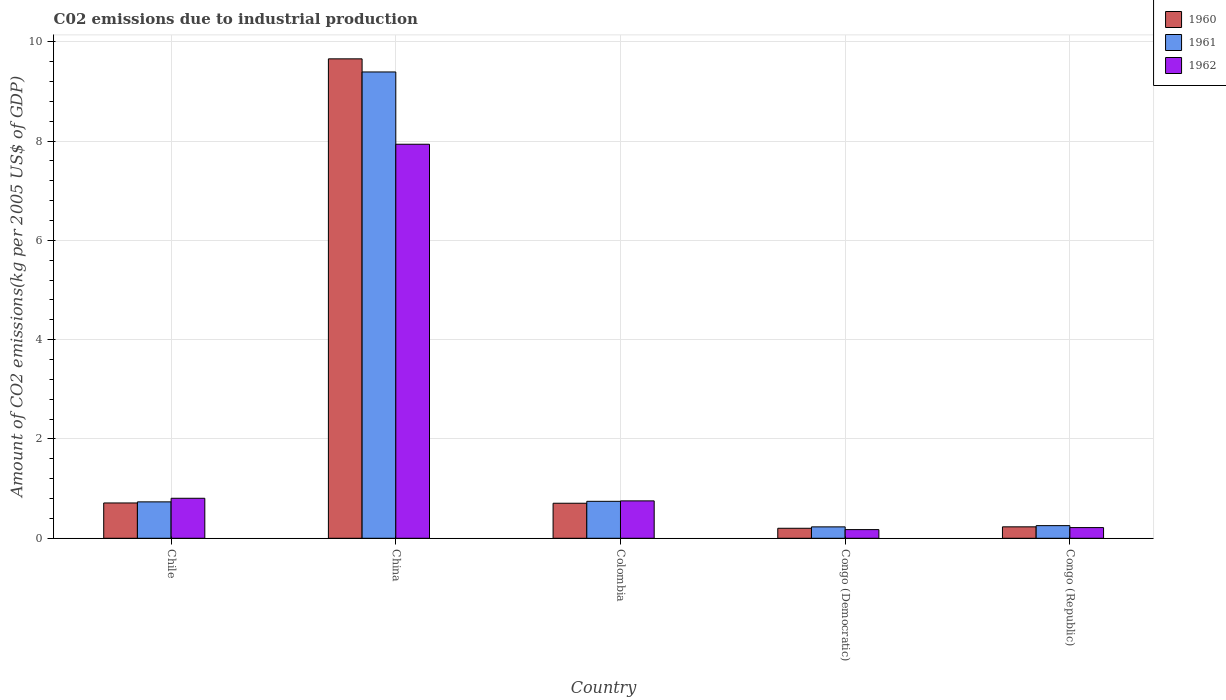How many different coloured bars are there?
Provide a succinct answer. 3. Are the number of bars per tick equal to the number of legend labels?
Provide a short and direct response. Yes. How many bars are there on the 1st tick from the left?
Your response must be concise. 3. What is the label of the 4th group of bars from the left?
Keep it short and to the point. Congo (Democratic). What is the amount of CO2 emitted due to industrial production in 1962 in China?
Your answer should be very brief. 7.94. Across all countries, what is the maximum amount of CO2 emitted due to industrial production in 1962?
Provide a short and direct response. 7.94. Across all countries, what is the minimum amount of CO2 emitted due to industrial production in 1961?
Provide a short and direct response. 0.23. In which country was the amount of CO2 emitted due to industrial production in 1962 maximum?
Your answer should be compact. China. In which country was the amount of CO2 emitted due to industrial production in 1962 minimum?
Offer a very short reply. Congo (Democratic). What is the total amount of CO2 emitted due to industrial production in 1960 in the graph?
Provide a short and direct response. 11.51. What is the difference between the amount of CO2 emitted due to industrial production in 1961 in China and that in Congo (Democratic)?
Provide a short and direct response. 9.16. What is the difference between the amount of CO2 emitted due to industrial production in 1962 in Congo (Democratic) and the amount of CO2 emitted due to industrial production in 1961 in Congo (Republic)?
Provide a short and direct response. -0.08. What is the average amount of CO2 emitted due to industrial production in 1962 per country?
Offer a very short reply. 1.98. What is the difference between the amount of CO2 emitted due to industrial production of/in 1962 and amount of CO2 emitted due to industrial production of/in 1961 in Colombia?
Offer a terse response. 0.01. What is the ratio of the amount of CO2 emitted due to industrial production in 1962 in China to that in Congo (Republic)?
Make the answer very short. 36.82. Is the difference between the amount of CO2 emitted due to industrial production in 1962 in China and Congo (Democratic) greater than the difference between the amount of CO2 emitted due to industrial production in 1961 in China and Congo (Democratic)?
Offer a very short reply. No. What is the difference between the highest and the second highest amount of CO2 emitted due to industrial production in 1962?
Your answer should be compact. 0.05. What is the difference between the highest and the lowest amount of CO2 emitted due to industrial production in 1962?
Offer a very short reply. 7.76. What does the 1st bar from the left in Colombia represents?
Keep it short and to the point. 1960. What does the 1st bar from the right in Congo (Republic) represents?
Offer a terse response. 1962. Is it the case that in every country, the sum of the amount of CO2 emitted due to industrial production in 1960 and amount of CO2 emitted due to industrial production in 1961 is greater than the amount of CO2 emitted due to industrial production in 1962?
Keep it short and to the point. Yes. How many bars are there?
Make the answer very short. 15. Are all the bars in the graph horizontal?
Provide a succinct answer. No. How many countries are there in the graph?
Ensure brevity in your answer.  5. Are the values on the major ticks of Y-axis written in scientific E-notation?
Offer a very short reply. No. Does the graph contain any zero values?
Your response must be concise. No. Where does the legend appear in the graph?
Your response must be concise. Top right. How are the legend labels stacked?
Your response must be concise. Vertical. What is the title of the graph?
Give a very brief answer. C02 emissions due to industrial production. What is the label or title of the Y-axis?
Your answer should be compact. Amount of CO2 emissions(kg per 2005 US$ of GDP). What is the Amount of CO2 emissions(kg per 2005 US$ of GDP) in 1960 in Chile?
Give a very brief answer. 0.71. What is the Amount of CO2 emissions(kg per 2005 US$ of GDP) of 1961 in Chile?
Offer a terse response. 0.73. What is the Amount of CO2 emissions(kg per 2005 US$ of GDP) in 1962 in Chile?
Make the answer very short. 0.81. What is the Amount of CO2 emissions(kg per 2005 US$ of GDP) in 1960 in China?
Give a very brief answer. 9.66. What is the Amount of CO2 emissions(kg per 2005 US$ of GDP) in 1961 in China?
Your answer should be compact. 9.39. What is the Amount of CO2 emissions(kg per 2005 US$ of GDP) of 1962 in China?
Your answer should be compact. 7.94. What is the Amount of CO2 emissions(kg per 2005 US$ of GDP) in 1960 in Colombia?
Provide a succinct answer. 0.71. What is the Amount of CO2 emissions(kg per 2005 US$ of GDP) of 1961 in Colombia?
Your answer should be very brief. 0.74. What is the Amount of CO2 emissions(kg per 2005 US$ of GDP) in 1962 in Colombia?
Your response must be concise. 0.75. What is the Amount of CO2 emissions(kg per 2005 US$ of GDP) in 1960 in Congo (Democratic)?
Keep it short and to the point. 0.2. What is the Amount of CO2 emissions(kg per 2005 US$ of GDP) of 1961 in Congo (Democratic)?
Keep it short and to the point. 0.23. What is the Amount of CO2 emissions(kg per 2005 US$ of GDP) of 1962 in Congo (Democratic)?
Your answer should be compact. 0.17. What is the Amount of CO2 emissions(kg per 2005 US$ of GDP) in 1960 in Congo (Republic)?
Ensure brevity in your answer.  0.23. What is the Amount of CO2 emissions(kg per 2005 US$ of GDP) of 1961 in Congo (Republic)?
Provide a succinct answer. 0.25. What is the Amount of CO2 emissions(kg per 2005 US$ of GDP) of 1962 in Congo (Republic)?
Provide a succinct answer. 0.22. Across all countries, what is the maximum Amount of CO2 emissions(kg per 2005 US$ of GDP) in 1960?
Provide a succinct answer. 9.66. Across all countries, what is the maximum Amount of CO2 emissions(kg per 2005 US$ of GDP) in 1961?
Make the answer very short. 9.39. Across all countries, what is the maximum Amount of CO2 emissions(kg per 2005 US$ of GDP) of 1962?
Make the answer very short. 7.94. Across all countries, what is the minimum Amount of CO2 emissions(kg per 2005 US$ of GDP) of 1960?
Provide a short and direct response. 0.2. Across all countries, what is the minimum Amount of CO2 emissions(kg per 2005 US$ of GDP) of 1961?
Provide a short and direct response. 0.23. Across all countries, what is the minimum Amount of CO2 emissions(kg per 2005 US$ of GDP) in 1962?
Give a very brief answer. 0.17. What is the total Amount of CO2 emissions(kg per 2005 US$ of GDP) in 1960 in the graph?
Keep it short and to the point. 11.51. What is the total Amount of CO2 emissions(kg per 2005 US$ of GDP) of 1961 in the graph?
Ensure brevity in your answer.  11.36. What is the total Amount of CO2 emissions(kg per 2005 US$ of GDP) of 1962 in the graph?
Your answer should be very brief. 9.89. What is the difference between the Amount of CO2 emissions(kg per 2005 US$ of GDP) of 1960 in Chile and that in China?
Keep it short and to the point. -8.95. What is the difference between the Amount of CO2 emissions(kg per 2005 US$ of GDP) in 1961 in Chile and that in China?
Provide a short and direct response. -8.66. What is the difference between the Amount of CO2 emissions(kg per 2005 US$ of GDP) of 1962 in Chile and that in China?
Keep it short and to the point. -7.13. What is the difference between the Amount of CO2 emissions(kg per 2005 US$ of GDP) in 1960 in Chile and that in Colombia?
Provide a succinct answer. 0.01. What is the difference between the Amount of CO2 emissions(kg per 2005 US$ of GDP) of 1961 in Chile and that in Colombia?
Keep it short and to the point. -0.01. What is the difference between the Amount of CO2 emissions(kg per 2005 US$ of GDP) of 1962 in Chile and that in Colombia?
Your answer should be very brief. 0.05. What is the difference between the Amount of CO2 emissions(kg per 2005 US$ of GDP) in 1960 in Chile and that in Congo (Democratic)?
Provide a short and direct response. 0.51. What is the difference between the Amount of CO2 emissions(kg per 2005 US$ of GDP) in 1961 in Chile and that in Congo (Democratic)?
Provide a short and direct response. 0.5. What is the difference between the Amount of CO2 emissions(kg per 2005 US$ of GDP) in 1962 in Chile and that in Congo (Democratic)?
Your answer should be very brief. 0.63. What is the difference between the Amount of CO2 emissions(kg per 2005 US$ of GDP) of 1960 in Chile and that in Congo (Republic)?
Give a very brief answer. 0.48. What is the difference between the Amount of CO2 emissions(kg per 2005 US$ of GDP) in 1961 in Chile and that in Congo (Republic)?
Your response must be concise. 0.48. What is the difference between the Amount of CO2 emissions(kg per 2005 US$ of GDP) of 1962 in Chile and that in Congo (Republic)?
Keep it short and to the point. 0.59. What is the difference between the Amount of CO2 emissions(kg per 2005 US$ of GDP) in 1960 in China and that in Colombia?
Keep it short and to the point. 8.95. What is the difference between the Amount of CO2 emissions(kg per 2005 US$ of GDP) of 1961 in China and that in Colombia?
Ensure brevity in your answer.  8.65. What is the difference between the Amount of CO2 emissions(kg per 2005 US$ of GDP) in 1962 in China and that in Colombia?
Your answer should be compact. 7.18. What is the difference between the Amount of CO2 emissions(kg per 2005 US$ of GDP) of 1960 in China and that in Congo (Democratic)?
Provide a succinct answer. 9.46. What is the difference between the Amount of CO2 emissions(kg per 2005 US$ of GDP) of 1961 in China and that in Congo (Democratic)?
Your answer should be compact. 9.16. What is the difference between the Amount of CO2 emissions(kg per 2005 US$ of GDP) in 1962 in China and that in Congo (Democratic)?
Make the answer very short. 7.76. What is the difference between the Amount of CO2 emissions(kg per 2005 US$ of GDP) of 1960 in China and that in Congo (Republic)?
Offer a terse response. 9.43. What is the difference between the Amount of CO2 emissions(kg per 2005 US$ of GDP) in 1961 in China and that in Congo (Republic)?
Provide a succinct answer. 9.14. What is the difference between the Amount of CO2 emissions(kg per 2005 US$ of GDP) of 1962 in China and that in Congo (Republic)?
Offer a terse response. 7.72. What is the difference between the Amount of CO2 emissions(kg per 2005 US$ of GDP) in 1960 in Colombia and that in Congo (Democratic)?
Your response must be concise. 0.5. What is the difference between the Amount of CO2 emissions(kg per 2005 US$ of GDP) of 1961 in Colombia and that in Congo (Democratic)?
Provide a succinct answer. 0.51. What is the difference between the Amount of CO2 emissions(kg per 2005 US$ of GDP) of 1962 in Colombia and that in Congo (Democratic)?
Ensure brevity in your answer.  0.58. What is the difference between the Amount of CO2 emissions(kg per 2005 US$ of GDP) of 1960 in Colombia and that in Congo (Republic)?
Provide a succinct answer. 0.48. What is the difference between the Amount of CO2 emissions(kg per 2005 US$ of GDP) of 1961 in Colombia and that in Congo (Republic)?
Ensure brevity in your answer.  0.49. What is the difference between the Amount of CO2 emissions(kg per 2005 US$ of GDP) in 1962 in Colombia and that in Congo (Republic)?
Your answer should be very brief. 0.54. What is the difference between the Amount of CO2 emissions(kg per 2005 US$ of GDP) in 1960 in Congo (Democratic) and that in Congo (Republic)?
Ensure brevity in your answer.  -0.03. What is the difference between the Amount of CO2 emissions(kg per 2005 US$ of GDP) of 1961 in Congo (Democratic) and that in Congo (Republic)?
Make the answer very short. -0.02. What is the difference between the Amount of CO2 emissions(kg per 2005 US$ of GDP) of 1962 in Congo (Democratic) and that in Congo (Republic)?
Provide a short and direct response. -0.04. What is the difference between the Amount of CO2 emissions(kg per 2005 US$ of GDP) of 1960 in Chile and the Amount of CO2 emissions(kg per 2005 US$ of GDP) of 1961 in China?
Give a very brief answer. -8.68. What is the difference between the Amount of CO2 emissions(kg per 2005 US$ of GDP) in 1960 in Chile and the Amount of CO2 emissions(kg per 2005 US$ of GDP) in 1962 in China?
Give a very brief answer. -7.23. What is the difference between the Amount of CO2 emissions(kg per 2005 US$ of GDP) in 1961 in Chile and the Amount of CO2 emissions(kg per 2005 US$ of GDP) in 1962 in China?
Ensure brevity in your answer.  -7.2. What is the difference between the Amount of CO2 emissions(kg per 2005 US$ of GDP) in 1960 in Chile and the Amount of CO2 emissions(kg per 2005 US$ of GDP) in 1961 in Colombia?
Your answer should be very brief. -0.03. What is the difference between the Amount of CO2 emissions(kg per 2005 US$ of GDP) in 1960 in Chile and the Amount of CO2 emissions(kg per 2005 US$ of GDP) in 1962 in Colombia?
Give a very brief answer. -0.04. What is the difference between the Amount of CO2 emissions(kg per 2005 US$ of GDP) in 1961 in Chile and the Amount of CO2 emissions(kg per 2005 US$ of GDP) in 1962 in Colombia?
Provide a short and direct response. -0.02. What is the difference between the Amount of CO2 emissions(kg per 2005 US$ of GDP) of 1960 in Chile and the Amount of CO2 emissions(kg per 2005 US$ of GDP) of 1961 in Congo (Democratic)?
Provide a short and direct response. 0.48. What is the difference between the Amount of CO2 emissions(kg per 2005 US$ of GDP) in 1960 in Chile and the Amount of CO2 emissions(kg per 2005 US$ of GDP) in 1962 in Congo (Democratic)?
Your answer should be very brief. 0.54. What is the difference between the Amount of CO2 emissions(kg per 2005 US$ of GDP) in 1961 in Chile and the Amount of CO2 emissions(kg per 2005 US$ of GDP) in 1962 in Congo (Democratic)?
Offer a very short reply. 0.56. What is the difference between the Amount of CO2 emissions(kg per 2005 US$ of GDP) in 1960 in Chile and the Amount of CO2 emissions(kg per 2005 US$ of GDP) in 1961 in Congo (Republic)?
Your answer should be compact. 0.46. What is the difference between the Amount of CO2 emissions(kg per 2005 US$ of GDP) of 1960 in Chile and the Amount of CO2 emissions(kg per 2005 US$ of GDP) of 1962 in Congo (Republic)?
Your response must be concise. 0.5. What is the difference between the Amount of CO2 emissions(kg per 2005 US$ of GDP) of 1961 in Chile and the Amount of CO2 emissions(kg per 2005 US$ of GDP) of 1962 in Congo (Republic)?
Give a very brief answer. 0.52. What is the difference between the Amount of CO2 emissions(kg per 2005 US$ of GDP) of 1960 in China and the Amount of CO2 emissions(kg per 2005 US$ of GDP) of 1961 in Colombia?
Provide a succinct answer. 8.91. What is the difference between the Amount of CO2 emissions(kg per 2005 US$ of GDP) in 1960 in China and the Amount of CO2 emissions(kg per 2005 US$ of GDP) in 1962 in Colombia?
Provide a succinct answer. 8.9. What is the difference between the Amount of CO2 emissions(kg per 2005 US$ of GDP) of 1961 in China and the Amount of CO2 emissions(kg per 2005 US$ of GDP) of 1962 in Colombia?
Offer a very short reply. 8.64. What is the difference between the Amount of CO2 emissions(kg per 2005 US$ of GDP) of 1960 in China and the Amount of CO2 emissions(kg per 2005 US$ of GDP) of 1961 in Congo (Democratic)?
Offer a very short reply. 9.43. What is the difference between the Amount of CO2 emissions(kg per 2005 US$ of GDP) in 1960 in China and the Amount of CO2 emissions(kg per 2005 US$ of GDP) in 1962 in Congo (Democratic)?
Ensure brevity in your answer.  9.48. What is the difference between the Amount of CO2 emissions(kg per 2005 US$ of GDP) in 1961 in China and the Amount of CO2 emissions(kg per 2005 US$ of GDP) in 1962 in Congo (Democratic)?
Your answer should be compact. 9.22. What is the difference between the Amount of CO2 emissions(kg per 2005 US$ of GDP) in 1960 in China and the Amount of CO2 emissions(kg per 2005 US$ of GDP) in 1961 in Congo (Republic)?
Make the answer very short. 9.4. What is the difference between the Amount of CO2 emissions(kg per 2005 US$ of GDP) in 1960 in China and the Amount of CO2 emissions(kg per 2005 US$ of GDP) in 1962 in Congo (Republic)?
Your response must be concise. 9.44. What is the difference between the Amount of CO2 emissions(kg per 2005 US$ of GDP) of 1961 in China and the Amount of CO2 emissions(kg per 2005 US$ of GDP) of 1962 in Congo (Republic)?
Your answer should be compact. 9.18. What is the difference between the Amount of CO2 emissions(kg per 2005 US$ of GDP) of 1960 in Colombia and the Amount of CO2 emissions(kg per 2005 US$ of GDP) of 1961 in Congo (Democratic)?
Ensure brevity in your answer.  0.48. What is the difference between the Amount of CO2 emissions(kg per 2005 US$ of GDP) in 1960 in Colombia and the Amount of CO2 emissions(kg per 2005 US$ of GDP) in 1962 in Congo (Democratic)?
Offer a very short reply. 0.53. What is the difference between the Amount of CO2 emissions(kg per 2005 US$ of GDP) in 1961 in Colombia and the Amount of CO2 emissions(kg per 2005 US$ of GDP) in 1962 in Congo (Democratic)?
Provide a short and direct response. 0.57. What is the difference between the Amount of CO2 emissions(kg per 2005 US$ of GDP) in 1960 in Colombia and the Amount of CO2 emissions(kg per 2005 US$ of GDP) in 1961 in Congo (Republic)?
Offer a very short reply. 0.45. What is the difference between the Amount of CO2 emissions(kg per 2005 US$ of GDP) in 1960 in Colombia and the Amount of CO2 emissions(kg per 2005 US$ of GDP) in 1962 in Congo (Republic)?
Offer a very short reply. 0.49. What is the difference between the Amount of CO2 emissions(kg per 2005 US$ of GDP) in 1961 in Colombia and the Amount of CO2 emissions(kg per 2005 US$ of GDP) in 1962 in Congo (Republic)?
Provide a succinct answer. 0.53. What is the difference between the Amount of CO2 emissions(kg per 2005 US$ of GDP) in 1960 in Congo (Democratic) and the Amount of CO2 emissions(kg per 2005 US$ of GDP) in 1961 in Congo (Republic)?
Your response must be concise. -0.05. What is the difference between the Amount of CO2 emissions(kg per 2005 US$ of GDP) of 1960 in Congo (Democratic) and the Amount of CO2 emissions(kg per 2005 US$ of GDP) of 1962 in Congo (Republic)?
Make the answer very short. -0.01. What is the difference between the Amount of CO2 emissions(kg per 2005 US$ of GDP) in 1961 in Congo (Democratic) and the Amount of CO2 emissions(kg per 2005 US$ of GDP) in 1962 in Congo (Republic)?
Offer a terse response. 0.01. What is the average Amount of CO2 emissions(kg per 2005 US$ of GDP) of 1960 per country?
Ensure brevity in your answer.  2.3. What is the average Amount of CO2 emissions(kg per 2005 US$ of GDP) of 1961 per country?
Provide a short and direct response. 2.27. What is the average Amount of CO2 emissions(kg per 2005 US$ of GDP) of 1962 per country?
Give a very brief answer. 1.98. What is the difference between the Amount of CO2 emissions(kg per 2005 US$ of GDP) in 1960 and Amount of CO2 emissions(kg per 2005 US$ of GDP) in 1961 in Chile?
Your response must be concise. -0.02. What is the difference between the Amount of CO2 emissions(kg per 2005 US$ of GDP) of 1960 and Amount of CO2 emissions(kg per 2005 US$ of GDP) of 1962 in Chile?
Offer a very short reply. -0.09. What is the difference between the Amount of CO2 emissions(kg per 2005 US$ of GDP) in 1961 and Amount of CO2 emissions(kg per 2005 US$ of GDP) in 1962 in Chile?
Make the answer very short. -0.07. What is the difference between the Amount of CO2 emissions(kg per 2005 US$ of GDP) of 1960 and Amount of CO2 emissions(kg per 2005 US$ of GDP) of 1961 in China?
Keep it short and to the point. 0.26. What is the difference between the Amount of CO2 emissions(kg per 2005 US$ of GDP) of 1960 and Amount of CO2 emissions(kg per 2005 US$ of GDP) of 1962 in China?
Give a very brief answer. 1.72. What is the difference between the Amount of CO2 emissions(kg per 2005 US$ of GDP) of 1961 and Amount of CO2 emissions(kg per 2005 US$ of GDP) of 1962 in China?
Ensure brevity in your answer.  1.46. What is the difference between the Amount of CO2 emissions(kg per 2005 US$ of GDP) of 1960 and Amount of CO2 emissions(kg per 2005 US$ of GDP) of 1961 in Colombia?
Offer a very short reply. -0.04. What is the difference between the Amount of CO2 emissions(kg per 2005 US$ of GDP) in 1960 and Amount of CO2 emissions(kg per 2005 US$ of GDP) in 1962 in Colombia?
Make the answer very short. -0.05. What is the difference between the Amount of CO2 emissions(kg per 2005 US$ of GDP) in 1961 and Amount of CO2 emissions(kg per 2005 US$ of GDP) in 1962 in Colombia?
Make the answer very short. -0.01. What is the difference between the Amount of CO2 emissions(kg per 2005 US$ of GDP) in 1960 and Amount of CO2 emissions(kg per 2005 US$ of GDP) in 1961 in Congo (Democratic)?
Make the answer very short. -0.03. What is the difference between the Amount of CO2 emissions(kg per 2005 US$ of GDP) in 1960 and Amount of CO2 emissions(kg per 2005 US$ of GDP) in 1962 in Congo (Democratic)?
Make the answer very short. 0.03. What is the difference between the Amount of CO2 emissions(kg per 2005 US$ of GDP) in 1961 and Amount of CO2 emissions(kg per 2005 US$ of GDP) in 1962 in Congo (Democratic)?
Provide a short and direct response. 0.05. What is the difference between the Amount of CO2 emissions(kg per 2005 US$ of GDP) of 1960 and Amount of CO2 emissions(kg per 2005 US$ of GDP) of 1961 in Congo (Republic)?
Give a very brief answer. -0.02. What is the difference between the Amount of CO2 emissions(kg per 2005 US$ of GDP) in 1960 and Amount of CO2 emissions(kg per 2005 US$ of GDP) in 1962 in Congo (Republic)?
Provide a short and direct response. 0.01. What is the difference between the Amount of CO2 emissions(kg per 2005 US$ of GDP) in 1961 and Amount of CO2 emissions(kg per 2005 US$ of GDP) in 1962 in Congo (Republic)?
Keep it short and to the point. 0.04. What is the ratio of the Amount of CO2 emissions(kg per 2005 US$ of GDP) of 1960 in Chile to that in China?
Ensure brevity in your answer.  0.07. What is the ratio of the Amount of CO2 emissions(kg per 2005 US$ of GDP) in 1961 in Chile to that in China?
Keep it short and to the point. 0.08. What is the ratio of the Amount of CO2 emissions(kg per 2005 US$ of GDP) in 1962 in Chile to that in China?
Give a very brief answer. 0.1. What is the ratio of the Amount of CO2 emissions(kg per 2005 US$ of GDP) of 1961 in Chile to that in Colombia?
Make the answer very short. 0.99. What is the ratio of the Amount of CO2 emissions(kg per 2005 US$ of GDP) in 1962 in Chile to that in Colombia?
Keep it short and to the point. 1.07. What is the ratio of the Amount of CO2 emissions(kg per 2005 US$ of GDP) of 1960 in Chile to that in Congo (Democratic)?
Ensure brevity in your answer.  3.53. What is the ratio of the Amount of CO2 emissions(kg per 2005 US$ of GDP) of 1961 in Chile to that in Congo (Democratic)?
Give a very brief answer. 3.19. What is the ratio of the Amount of CO2 emissions(kg per 2005 US$ of GDP) in 1962 in Chile to that in Congo (Democratic)?
Keep it short and to the point. 4.61. What is the ratio of the Amount of CO2 emissions(kg per 2005 US$ of GDP) in 1960 in Chile to that in Congo (Republic)?
Make the answer very short. 3.08. What is the ratio of the Amount of CO2 emissions(kg per 2005 US$ of GDP) of 1961 in Chile to that in Congo (Republic)?
Offer a very short reply. 2.88. What is the ratio of the Amount of CO2 emissions(kg per 2005 US$ of GDP) in 1962 in Chile to that in Congo (Republic)?
Your answer should be compact. 3.74. What is the ratio of the Amount of CO2 emissions(kg per 2005 US$ of GDP) of 1960 in China to that in Colombia?
Ensure brevity in your answer.  13.68. What is the ratio of the Amount of CO2 emissions(kg per 2005 US$ of GDP) in 1961 in China to that in Colombia?
Give a very brief answer. 12.62. What is the ratio of the Amount of CO2 emissions(kg per 2005 US$ of GDP) in 1962 in China to that in Colombia?
Make the answer very short. 10.54. What is the ratio of the Amount of CO2 emissions(kg per 2005 US$ of GDP) in 1960 in China to that in Congo (Democratic)?
Keep it short and to the point. 47.89. What is the ratio of the Amount of CO2 emissions(kg per 2005 US$ of GDP) in 1961 in China to that in Congo (Democratic)?
Your response must be concise. 40.88. What is the ratio of the Amount of CO2 emissions(kg per 2005 US$ of GDP) of 1962 in China to that in Congo (Democratic)?
Make the answer very short. 45.4. What is the ratio of the Amount of CO2 emissions(kg per 2005 US$ of GDP) in 1960 in China to that in Congo (Republic)?
Ensure brevity in your answer.  41.88. What is the ratio of the Amount of CO2 emissions(kg per 2005 US$ of GDP) of 1961 in China to that in Congo (Republic)?
Provide a short and direct response. 36.88. What is the ratio of the Amount of CO2 emissions(kg per 2005 US$ of GDP) of 1962 in China to that in Congo (Republic)?
Your answer should be very brief. 36.82. What is the ratio of the Amount of CO2 emissions(kg per 2005 US$ of GDP) of 1961 in Colombia to that in Congo (Democratic)?
Provide a short and direct response. 3.24. What is the ratio of the Amount of CO2 emissions(kg per 2005 US$ of GDP) of 1962 in Colombia to that in Congo (Democratic)?
Your answer should be compact. 4.31. What is the ratio of the Amount of CO2 emissions(kg per 2005 US$ of GDP) in 1960 in Colombia to that in Congo (Republic)?
Ensure brevity in your answer.  3.06. What is the ratio of the Amount of CO2 emissions(kg per 2005 US$ of GDP) of 1961 in Colombia to that in Congo (Republic)?
Offer a very short reply. 2.92. What is the ratio of the Amount of CO2 emissions(kg per 2005 US$ of GDP) in 1962 in Colombia to that in Congo (Republic)?
Your answer should be very brief. 3.49. What is the ratio of the Amount of CO2 emissions(kg per 2005 US$ of GDP) of 1960 in Congo (Democratic) to that in Congo (Republic)?
Provide a short and direct response. 0.87. What is the ratio of the Amount of CO2 emissions(kg per 2005 US$ of GDP) in 1961 in Congo (Democratic) to that in Congo (Republic)?
Ensure brevity in your answer.  0.9. What is the ratio of the Amount of CO2 emissions(kg per 2005 US$ of GDP) of 1962 in Congo (Democratic) to that in Congo (Republic)?
Keep it short and to the point. 0.81. What is the difference between the highest and the second highest Amount of CO2 emissions(kg per 2005 US$ of GDP) in 1960?
Provide a succinct answer. 8.95. What is the difference between the highest and the second highest Amount of CO2 emissions(kg per 2005 US$ of GDP) of 1961?
Give a very brief answer. 8.65. What is the difference between the highest and the second highest Amount of CO2 emissions(kg per 2005 US$ of GDP) of 1962?
Your response must be concise. 7.13. What is the difference between the highest and the lowest Amount of CO2 emissions(kg per 2005 US$ of GDP) in 1960?
Your response must be concise. 9.46. What is the difference between the highest and the lowest Amount of CO2 emissions(kg per 2005 US$ of GDP) in 1961?
Make the answer very short. 9.16. What is the difference between the highest and the lowest Amount of CO2 emissions(kg per 2005 US$ of GDP) of 1962?
Keep it short and to the point. 7.76. 